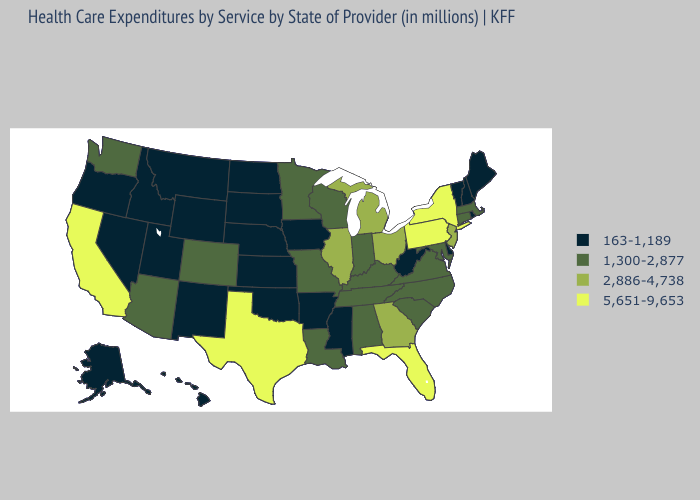What is the value of Washington?
Write a very short answer. 1,300-2,877. Does New Hampshire have the highest value in the Northeast?
Write a very short answer. No. Does the map have missing data?
Answer briefly. No. Does New Hampshire have a lower value than Kentucky?
Be succinct. Yes. Is the legend a continuous bar?
Answer briefly. No. What is the value of Nebraska?
Short answer required. 163-1,189. What is the value of Arizona?
Answer briefly. 1,300-2,877. Does Pennsylvania have a higher value than Rhode Island?
Be succinct. Yes. Name the states that have a value in the range 163-1,189?
Give a very brief answer. Alaska, Arkansas, Delaware, Hawaii, Idaho, Iowa, Kansas, Maine, Mississippi, Montana, Nebraska, Nevada, New Hampshire, New Mexico, North Dakota, Oklahoma, Oregon, Rhode Island, South Dakota, Utah, Vermont, West Virginia, Wyoming. How many symbols are there in the legend?
Write a very short answer. 4. Among the states that border Nevada , which have the highest value?
Concise answer only. California. Does the first symbol in the legend represent the smallest category?
Keep it brief. Yes. Does Massachusetts have the highest value in the USA?
Quick response, please. No. Does New York have the highest value in the USA?
Give a very brief answer. Yes. Does Kansas have the lowest value in the USA?
Answer briefly. Yes. 